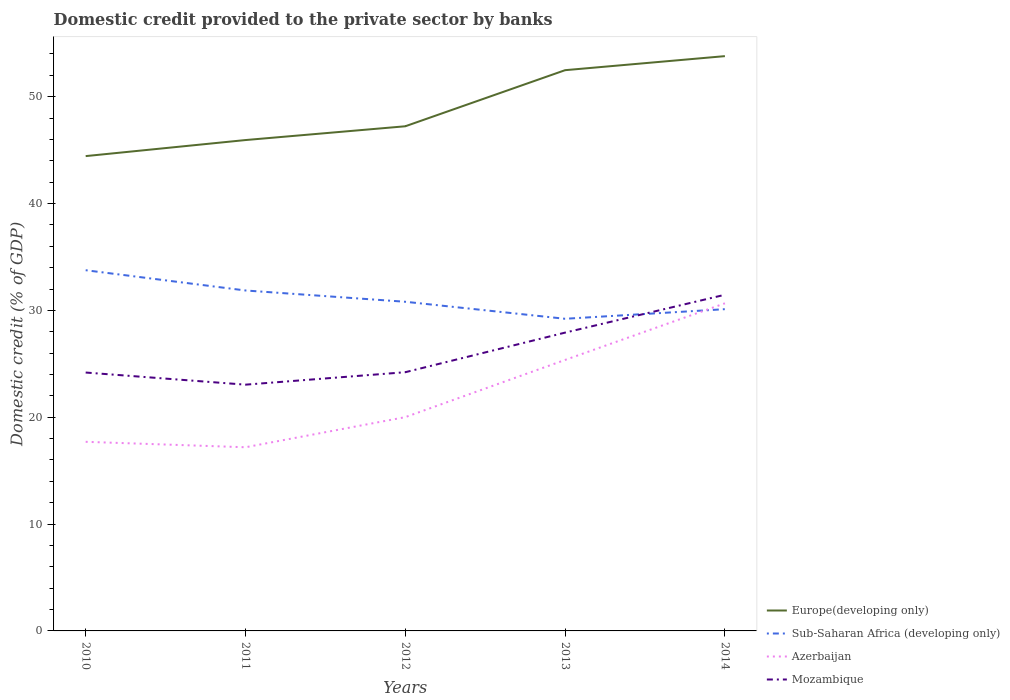Across all years, what is the maximum domestic credit provided to the private sector by banks in Sub-Saharan Africa (developing only)?
Offer a very short reply. 29.21. What is the total domestic credit provided to the private sector by banks in Mozambique in the graph?
Ensure brevity in your answer.  -3.54. What is the difference between the highest and the second highest domestic credit provided to the private sector by banks in Azerbaijan?
Keep it short and to the point. 13.47. What is the difference between the highest and the lowest domestic credit provided to the private sector by banks in Azerbaijan?
Your answer should be compact. 2. Is the domestic credit provided to the private sector by banks in Europe(developing only) strictly greater than the domestic credit provided to the private sector by banks in Azerbaijan over the years?
Your response must be concise. No. How many lines are there?
Your response must be concise. 4. How many years are there in the graph?
Your response must be concise. 5. Are the values on the major ticks of Y-axis written in scientific E-notation?
Provide a succinct answer. No. Does the graph contain grids?
Offer a terse response. No. How many legend labels are there?
Your answer should be compact. 4. How are the legend labels stacked?
Ensure brevity in your answer.  Vertical. What is the title of the graph?
Keep it short and to the point. Domestic credit provided to the private sector by banks. Does "Namibia" appear as one of the legend labels in the graph?
Offer a terse response. No. What is the label or title of the X-axis?
Provide a short and direct response. Years. What is the label or title of the Y-axis?
Give a very brief answer. Domestic credit (% of GDP). What is the Domestic credit (% of GDP) in Europe(developing only) in 2010?
Provide a succinct answer. 44.44. What is the Domestic credit (% of GDP) in Sub-Saharan Africa (developing only) in 2010?
Give a very brief answer. 33.76. What is the Domestic credit (% of GDP) in Azerbaijan in 2010?
Make the answer very short. 17.7. What is the Domestic credit (% of GDP) in Mozambique in 2010?
Provide a short and direct response. 24.18. What is the Domestic credit (% of GDP) in Europe(developing only) in 2011?
Make the answer very short. 45.94. What is the Domestic credit (% of GDP) in Sub-Saharan Africa (developing only) in 2011?
Ensure brevity in your answer.  31.86. What is the Domestic credit (% of GDP) in Azerbaijan in 2011?
Your answer should be compact. 17.19. What is the Domestic credit (% of GDP) of Mozambique in 2011?
Provide a short and direct response. 23.05. What is the Domestic credit (% of GDP) of Europe(developing only) in 2012?
Make the answer very short. 47.23. What is the Domestic credit (% of GDP) of Sub-Saharan Africa (developing only) in 2012?
Your answer should be compact. 30.81. What is the Domestic credit (% of GDP) of Azerbaijan in 2012?
Make the answer very short. 20.01. What is the Domestic credit (% of GDP) of Mozambique in 2012?
Give a very brief answer. 24.21. What is the Domestic credit (% of GDP) in Europe(developing only) in 2013?
Offer a terse response. 52.48. What is the Domestic credit (% of GDP) of Sub-Saharan Africa (developing only) in 2013?
Make the answer very short. 29.21. What is the Domestic credit (% of GDP) in Azerbaijan in 2013?
Your answer should be compact. 25.36. What is the Domestic credit (% of GDP) in Mozambique in 2013?
Make the answer very short. 27.92. What is the Domestic credit (% of GDP) in Europe(developing only) in 2014?
Your answer should be compact. 53.79. What is the Domestic credit (% of GDP) of Sub-Saharan Africa (developing only) in 2014?
Offer a very short reply. 30.11. What is the Domestic credit (% of GDP) in Azerbaijan in 2014?
Keep it short and to the point. 30.66. What is the Domestic credit (% of GDP) of Mozambique in 2014?
Make the answer very short. 31.46. Across all years, what is the maximum Domestic credit (% of GDP) of Europe(developing only)?
Give a very brief answer. 53.79. Across all years, what is the maximum Domestic credit (% of GDP) in Sub-Saharan Africa (developing only)?
Provide a short and direct response. 33.76. Across all years, what is the maximum Domestic credit (% of GDP) in Azerbaijan?
Your response must be concise. 30.66. Across all years, what is the maximum Domestic credit (% of GDP) of Mozambique?
Offer a terse response. 31.46. Across all years, what is the minimum Domestic credit (% of GDP) in Europe(developing only)?
Give a very brief answer. 44.44. Across all years, what is the minimum Domestic credit (% of GDP) of Sub-Saharan Africa (developing only)?
Keep it short and to the point. 29.21. Across all years, what is the minimum Domestic credit (% of GDP) of Azerbaijan?
Give a very brief answer. 17.19. Across all years, what is the minimum Domestic credit (% of GDP) of Mozambique?
Your answer should be very brief. 23.05. What is the total Domestic credit (% of GDP) of Europe(developing only) in the graph?
Your answer should be very brief. 243.88. What is the total Domestic credit (% of GDP) of Sub-Saharan Africa (developing only) in the graph?
Provide a short and direct response. 155.75. What is the total Domestic credit (% of GDP) in Azerbaijan in the graph?
Provide a short and direct response. 110.92. What is the total Domestic credit (% of GDP) in Mozambique in the graph?
Give a very brief answer. 130.82. What is the difference between the Domestic credit (% of GDP) of Europe(developing only) in 2010 and that in 2011?
Make the answer very short. -1.5. What is the difference between the Domestic credit (% of GDP) of Sub-Saharan Africa (developing only) in 2010 and that in 2011?
Your response must be concise. 1.9. What is the difference between the Domestic credit (% of GDP) in Azerbaijan in 2010 and that in 2011?
Offer a very short reply. 0.51. What is the difference between the Domestic credit (% of GDP) in Mozambique in 2010 and that in 2011?
Your answer should be compact. 1.14. What is the difference between the Domestic credit (% of GDP) in Europe(developing only) in 2010 and that in 2012?
Make the answer very short. -2.79. What is the difference between the Domestic credit (% of GDP) of Sub-Saharan Africa (developing only) in 2010 and that in 2012?
Give a very brief answer. 2.95. What is the difference between the Domestic credit (% of GDP) of Azerbaijan in 2010 and that in 2012?
Your response must be concise. -2.31. What is the difference between the Domestic credit (% of GDP) in Mozambique in 2010 and that in 2012?
Make the answer very short. -0.03. What is the difference between the Domestic credit (% of GDP) of Europe(developing only) in 2010 and that in 2013?
Provide a short and direct response. -8.04. What is the difference between the Domestic credit (% of GDP) of Sub-Saharan Africa (developing only) in 2010 and that in 2013?
Offer a terse response. 4.55. What is the difference between the Domestic credit (% of GDP) in Azerbaijan in 2010 and that in 2013?
Ensure brevity in your answer.  -7.66. What is the difference between the Domestic credit (% of GDP) of Mozambique in 2010 and that in 2013?
Your response must be concise. -3.74. What is the difference between the Domestic credit (% of GDP) of Europe(developing only) in 2010 and that in 2014?
Make the answer very short. -9.36. What is the difference between the Domestic credit (% of GDP) in Sub-Saharan Africa (developing only) in 2010 and that in 2014?
Your response must be concise. 3.65. What is the difference between the Domestic credit (% of GDP) in Azerbaijan in 2010 and that in 2014?
Give a very brief answer. -12.96. What is the difference between the Domestic credit (% of GDP) in Mozambique in 2010 and that in 2014?
Your answer should be very brief. -7.28. What is the difference between the Domestic credit (% of GDP) of Europe(developing only) in 2011 and that in 2012?
Offer a very short reply. -1.29. What is the difference between the Domestic credit (% of GDP) in Sub-Saharan Africa (developing only) in 2011 and that in 2012?
Give a very brief answer. 1.06. What is the difference between the Domestic credit (% of GDP) of Azerbaijan in 2011 and that in 2012?
Ensure brevity in your answer.  -2.82. What is the difference between the Domestic credit (% of GDP) in Mozambique in 2011 and that in 2012?
Offer a terse response. -1.17. What is the difference between the Domestic credit (% of GDP) of Europe(developing only) in 2011 and that in 2013?
Give a very brief answer. -6.54. What is the difference between the Domestic credit (% of GDP) of Sub-Saharan Africa (developing only) in 2011 and that in 2013?
Give a very brief answer. 2.65. What is the difference between the Domestic credit (% of GDP) in Azerbaijan in 2011 and that in 2013?
Offer a very short reply. -8.17. What is the difference between the Domestic credit (% of GDP) of Mozambique in 2011 and that in 2013?
Offer a very short reply. -4.87. What is the difference between the Domestic credit (% of GDP) of Europe(developing only) in 2011 and that in 2014?
Your answer should be compact. -7.85. What is the difference between the Domestic credit (% of GDP) in Azerbaijan in 2011 and that in 2014?
Offer a terse response. -13.47. What is the difference between the Domestic credit (% of GDP) of Mozambique in 2011 and that in 2014?
Offer a terse response. -8.41. What is the difference between the Domestic credit (% of GDP) of Europe(developing only) in 2012 and that in 2013?
Provide a short and direct response. -5.25. What is the difference between the Domestic credit (% of GDP) of Sub-Saharan Africa (developing only) in 2012 and that in 2013?
Offer a very short reply. 1.59. What is the difference between the Domestic credit (% of GDP) of Azerbaijan in 2012 and that in 2013?
Your answer should be compact. -5.35. What is the difference between the Domestic credit (% of GDP) of Mozambique in 2012 and that in 2013?
Give a very brief answer. -3.71. What is the difference between the Domestic credit (% of GDP) in Europe(developing only) in 2012 and that in 2014?
Provide a short and direct response. -6.56. What is the difference between the Domestic credit (% of GDP) of Sub-Saharan Africa (developing only) in 2012 and that in 2014?
Your answer should be compact. 0.69. What is the difference between the Domestic credit (% of GDP) of Azerbaijan in 2012 and that in 2014?
Your response must be concise. -10.65. What is the difference between the Domestic credit (% of GDP) in Mozambique in 2012 and that in 2014?
Keep it short and to the point. -7.25. What is the difference between the Domestic credit (% of GDP) of Europe(developing only) in 2013 and that in 2014?
Your answer should be compact. -1.31. What is the difference between the Domestic credit (% of GDP) in Sub-Saharan Africa (developing only) in 2013 and that in 2014?
Make the answer very short. -0.9. What is the difference between the Domestic credit (% of GDP) of Azerbaijan in 2013 and that in 2014?
Make the answer very short. -5.3. What is the difference between the Domestic credit (% of GDP) of Mozambique in 2013 and that in 2014?
Your answer should be very brief. -3.54. What is the difference between the Domestic credit (% of GDP) of Europe(developing only) in 2010 and the Domestic credit (% of GDP) of Sub-Saharan Africa (developing only) in 2011?
Ensure brevity in your answer.  12.58. What is the difference between the Domestic credit (% of GDP) in Europe(developing only) in 2010 and the Domestic credit (% of GDP) in Azerbaijan in 2011?
Make the answer very short. 27.25. What is the difference between the Domestic credit (% of GDP) of Europe(developing only) in 2010 and the Domestic credit (% of GDP) of Mozambique in 2011?
Your answer should be very brief. 21.39. What is the difference between the Domestic credit (% of GDP) of Sub-Saharan Africa (developing only) in 2010 and the Domestic credit (% of GDP) of Azerbaijan in 2011?
Ensure brevity in your answer.  16.57. What is the difference between the Domestic credit (% of GDP) in Sub-Saharan Africa (developing only) in 2010 and the Domestic credit (% of GDP) in Mozambique in 2011?
Your answer should be compact. 10.71. What is the difference between the Domestic credit (% of GDP) in Azerbaijan in 2010 and the Domestic credit (% of GDP) in Mozambique in 2011?
Give a very brief answer. -5.35. What is the difference between the Domestic credit (% of GDP) of Europe(developing only) in 2010 and the Domestic credit (% of GDP) of Sub-Saharan Africa (developing only) in 2012?
Provide a succinct answer. 13.63. What is the difference between the Domestic credit (% of GDP) of Europe(developing only) in 2010 and the Domestic credit (% of GDP) of Azerbaijan in 2012?
Provide a succinct answer. 24.43. What is the difference between the Domestic credit (% of GDP) in Europe(developing only) in 2010 and the Domestic credit (% of GDP) in Mozambique in 2012?
Your answer should be very brief. 20.23. What is the difference between the Domestic credit (% of GDP) in Sub-Saharan Africa (developing only) in 2010 and the Domestic credit (% of GDP) in Azerbaijan in 2012?
Offer a very short reply. 13.75. What is the difference between the Domestic credit (% of GDP) in Sub-Saharan Africa (developing only) in 2010 and the Domestic credit (% of GDP) in Mozambique in 2012?
Your response must be concise. 9.55. What is the difference between the Domestic credit (% of GDP) in Azerbaijan in 2010 and the Domestic credit (% of GDP) in Mozambique in 2012?
Ensure brevity in your answer.  -6.51. What is the difference between the Domestic credit (% of GDP) in Europe(developing only) in 2010 and the Domestic credit (% of GDP) in Sub-Saharan Africa (developing only) in 2013?
Your response must be concise. 15.23. What is the difference between the Domestic credit (% of GDP) of Europe(developing only) in 2010 and the Domestic credit (% of GDP) of Azerbaijan in 2013?
Your answer should be very brief. 19.08. What is the difference between the Domestic credit (% of GDP) in Europe(developing only) in 2010 and the Domestic credit (% of GDP) in Mozambique in 2013?
Your answer should be compact. 16.52. What is the difference between the Domestic credit (% of GDP) in Sub-Saharan Africa (developing only) in 2010 and the Domestic credit (% of GDP) in Azerbaijan in 2013?
Keep it short and to the point. 8.4. What is the difference between the Domestic credit (% of GDP) in Sub-Saharan Africa (developing only) in 2010 and the Domestic credit (% of GDP) in Mozambique in 2013?
Your answer should be very brief. 5.84. What is the difference between the Domestic credit (% of GDP) in Azerbaijan in 2010 and the Domestic credit (% of GDP) in Mozambique in 2013?
Ensure brevity in your answer.  -10.22. What is the difference between the Domestic credit (% of GDP) in Europe(developing only) in 2010 and the Domestic credit (% of GDP) in Sub-Saharan Africa (developing only) in 2014?
Offer a terse response. 14.33. What is the difference between the Domestic credit (% of GDP) of Europe(developing only) in 2010 and the Domestic credit (% of GDP) of Azerbaijan in 2014?
Your answer should be very brief. 13.78. What is the difference between the Domestic credit (% of GDP) in Europe(developing only) in 2010 and the Domestic credit (% of GDP) in Mozambique in 2014?
Make the answer very short. 12.98. What is the difference between the Domestic credit (% of GDP) of Sub-Saharan Africa (developing only) in 2010 and the Domestic credit (% of GDP) of Azerbaijan in 2014?
Make the answer very short. 3.1. What is the difference between the Domestic credit (% of GDP) in Sub-Saharan Africa (developing only) in 2010 and the Domestic credit (% of GDP) in Mozambique in 2014?
Offer a terse response. 2.3. What is the difference between the Domestic credit (% of GDP) of Azerbaijan in 2010 and the Domestic credit (% of GDP) of Mozambique in 2014?
Your answer should be compact. -13.76. What is the difference between the Domestic credit (% of GDP) of Europe(developing only) in 2011 and the Domestic credit (% of GDP) of Sub-Saharan Africa (developing only) in 2012?
Make the answer very short. 15.13. What is the difference between the Domestic credit (% of GDP) in Europe(developing only) in 2011 and the Domestic credit (% of GDP) in Azerbaijan in 2012?
Your answer should be compact. 25.93. What is the difference between the Domestic credit (% of GDP) in Europe(developing only) in 2011 and the Domestic credit (% of GDP) in Mozambique in 2012?
Keep it short and to the point. 21.73. What is the difference between the Domestic credit (% of GDP) in Sub-Saharan Africa (developing only) in 2011 and the Domestic credit (% of GDP) in Azerbaijan in 2012?
Make the answer very short. 11.85. What is the difference between the Domestic credit (% of GDP) in Sub-Saharan Africa (developing only) in 2011 and the Domestic credit (% of GDP) in Mozambique in 2012?
Offer a terse response. 7.65. What is the difference between the Domestic credit (% of GDP) in Azerbaijan in 2011 and the Domestic credit (% of GDP) in Mozambique in 2012?
Provide a short and direct response. -7.02. What is the difference between the Domestic credit (% of GDP) in Europe(developing only) in 2011 and the Domestic credit (% of GDP) in Sub-Saharan Africa (developing only) in 2013?
Your response must be concise. 16.73. What is the difference between the Domestic credit (% of GDP) of Europe(developing only) in 2011 and the Domestic credit (% of GDP) of Azerbaijan in 2013?
Offer a terse response. 20.58. What is the difference between the Domestic credit (% of GDP) of Europe(developing only) in 2011 and the Domestic credit (% of GDP) of Mozambique in 2013?
Your answer should be very brief. 18.02. What is the difference between the Domestic credit (% of GDP) in Sub-Saharan Africa (developing only) in 2011 and the Domestic credit (% of GDP) in Mozambique in 2013?
Your answer should be compact. 3.94. What is the difference between the Domestic credit (% of GDP) of Azerbaijan in 2011 and the Domestic credit (% of GDP) of Mozambique in 2013?
Give a very brief answer. -10.73. What is the difference between the Domestic credit (% of GDP) in Europe(developing only) in 2011 and the Domestic credit (% of GDP) in Sub-Saharan Africa (developing only) in 2014?
Provide a short and direct response. 15.83. What is the difference between the Domestic credit (% of GDP) of Europe(developing only) in 2011 and the Domestic credit (% of GDP) of Azerbaijan in 2014?
Offer a terse response. 15.28. What is the difference between the Domestic credit (% of GDP) of Europe(developing only) in 2011 and the Domestic credit (% of GDP) of Mozambique in 2014?
Provide a short and direct response. 14.48. What is the difference between the Domestic credit (% of GDP) in Sub-Saharan Africa (developing only) in 2011 and the Domestic credit (% of GDP) in Azerbaijan in 2014?
Provide a succinct answer. 1.2. What is the difference between the Domestic credit (% of GDP) in Sub-Saharan Africa (developing only) in 2011 and the Domestic credit (% of GDP) in Mozambique in 2014?
Offer a terse response. 0.4. What is the difference between the Domestic credit (% of GDP) in Azerbaijan in 2011 and the Domestic credit (% of GDP) in Mozambique in 2014?
Your answer should be compact. -14.27. What is the difference between the Domestic credit (% of GDP) of Europe(developing only) in 2012 and the Domestic credit (% of GDP) of Sub-Saharan Africa (developing only) in 2013?
Keep it short and to the point. 18.02. What is the difference between the Domestic credit (% of GDP) of Europe(developing only) in 2012 and the Domestic credit (% of GDP) of Azerbaijan in 2013?
Your response must be concise. 21.87. What is the difference between the Domestic credit (% of GDP) of Europe(developing only) in 2012 and the Domestic credit (% of GDP) of Mozambique in 2013?
Your response must be concise. 19.31. What is the difference between the Domestic credit (% of GDP) in Sub-Saharan Africa (developing only) in 2012 and the Domestic credit (% of GDP) in Azerbaijan in 2013?
Provide a succinct answer. 5.44. What is the difference between the Domestic credit (% of GDP) of Sub-Saharan Africa (developing only) in 2012 and the Domestic credit (% of GDP) of Mozambique in 2013?
Ensure brevity in your answer.  2.89. What is the difference between the Domestic credit (% of GDP) of Azerbaijan in 2012 and the Domestic credit (% of GDP) of Mozambique in 2013?
Provide a short and direct response. -7.91. What is the difference between the Domestic credit (% of GDP) of Europe(developing only) in 2012 and the Domestic credit (% of GDP) of Sub-Saharan Africa (developing only) in 2014?
Make the answer very short. 17.12. What is the difference between the Domestic credit (% of GDP) of Europe(developing only) in 2012 and the Domestic credit (% of GDP) of Azerbaijan in 2014?
Give a very brief answer. 16.57. What is the difference between the Domestic credit (% of GDP) in Europe(developing only) in 2012 and the Domestic credit (% of GDP) in Mozambique in 2014?
Keep it short and to the point. 15.77. What is the difference between the Domestic credit (% of GDP) in Sub-Saharan Africa (developing only) in 2012 and the Domestic credit (% of GDP) in Azerbaijan in 2014?
Your answer should be compact. 0.14. What is the difference between the Domestic credit (% of GDP) of Sub-Saharan Africa (developing only) in 2012 and the Domestic credit (% of GDP) of Mozambique in 2014?
Your answer should be compact. -0.66. What is the difference between the Domestic credit (% of GDP) in Azerbaijan in 2012 and the Domestic credit (% of GDP) in Mozambique in 2014?
Give a very brief answer. -11.45. What is the difference between the Domestic credit (% of GDP) in Europe(developing only) in 2013 and the Domestic credit (% of GDP) in Sub-Saharan Africa (developing only) in 2014?
Give a very brief answer. 22.37. What is the difference between the Domestic credit (% of GDP) in Europe(developing only) in 2013 and the Domestic credit (% of GDP) in Azerbaijan in 2014?
Your answer should be very brief. 21.82. What is the difference between the Domestic credit (% of GDP) of Europe(developing only) in 2013 and the Domestic credit (% of GDP) of Mozambique in 2014?
Provide a short and direct response. 21.02. What is the difference between the Domestic credit (% of GDP) in Sub-Saharan Africa (developing only) in 2013 and the Domestic credit (% of GDP) in Azerbaijan in 2014?
Give a very brief answer. -1.45. What is the difference between the Domestic credit (% of GDP) of Sub-Saharan Africa (developing only) in 2013 and the Domestic credit (% of GDP) of Mozambique in 2014?
Your response must be concise. -2.25. What is the difference between the Domestic credit (% of GDP) in Azerbaijan in 2013 and the Domestic credit (% of GDP) in Mozambique in 2014?
Make the answer very short. -6.1. What is the average Domestic credit (% of GDP) of Europe(developing only) per year?
Keep it short and to the point. 48.78. What is the average Domestic credit (% of GDP) of Sub-Saharan Africa (developing only) per year?
Keep it short and to the point. 31.15. What is the average Domestic credit (% of GDP) in Azerbaijan per year?
Your response must be concise. 22.18. What is the average Domestic credit (% of GDP) of Mozambique per year?
Provide a short and direct response. 26.16. In the year 2010, what is the difference between the Domestic credit (% of GDP) of Europe(developing only) and Domestic credit (% of GDP) of Sub-Saharan Africa (developing only)?
Offer a very short reply. 10.68. In the year 2010, what is the difference between the Domestic credit (% of GDP) of Europe(developing only) and Domestic credit (% of GDP) of Azerbaijan?
Keep it short and to the point. 26.74. In the year 2010, what is the difference between the Domestic credit (% of GDP) in Europe(developing only) and Domestic credit (% of GDP) in Mozambique?
Offer a terse response. 20.26. In the year 2010, what is the difference between the Domestic credit (% of GDP) of Sub-Saharan Africa (developing only) and Domestic credit (% of GDP) of Azerbaijan?
Offer a terse response. 16.06. In the year 2010, what is the difference between the Domestic credit (% of GDP) in Sub-Saharan Africa (developing only) and Domestic credit (% of GDP) in Mozambique?
Ensure brevity in your answer.  9.58. In the year 2010, what is the difference between the Domestic credit (% of GDP) in Azerbaijan and Domestic credit (% of GDP) in Mozambique?
Provide a succinct answer. -6.48. In the year 2011, what is the difference between the Domestic credit (% of GDP) in Europe(developing only) and Domestic credit (% of GDP) in Sub-Saharan Africa (developing only)?
Ensure brevity in your answer.  14.08. In the year 2011, what is the difference between the Domestic credit (% of GDP) of Europe(developing only) and Domestic credit (% of GDP) of Azerbaijan?
Make the answer very short. 28.75. In the year 2011, what is the difference between the Domestic credit (% of GDP) in Europe(developing only) and Domestic credit (% of GDP) in Mozambique?
Make the answer very short. 22.89. In the year 2011, what is the difference between the Domestic credit (% of GDP) in Sub-Saharan Africa (developing only) and Domestic credit (% of GDP) in Azerbaijan?
Offer a terse response. 14.67. In the year 2011, what is the difference between the Domestic credit (% of GDP) in Sub-Saharan Africa (developing only) and Domestic credit (% of GDP) in Mozambique?
Your response must be concise. 8.82. In the year 2011, what is the difference between the Domestic credit (% of GDP) of Azerbaijan and Domestic credit (% of GDP) of Mozambique?
Provide a short and direct response. -5.86. In the year 2012, what is the difference between the Domestic credit (% of GDP) in Europe(developing only) and Domestic credit (% of GDP) in Sub-Saharan Africa (developing only)?
Provide a short and direct response. 16.42. In the year 2012, what is the difference between the Domestic credit (% of GDP) of Europe(developing only) and Domestic credit (% of GDP) of Azerbaijan?
Offer a very short reply. 27.22. In the year 2012, what is the difference between the Domestic credit (% of GDP) in Europe(developing only) and Domestic credit (% of GDP) in Mozambique?
Ensure brevity in your answer.  23.02. In the year 2012, what is the difference between the Domestic credit (% of GDP) in Sub-Saharan Africa (developing only) and Domestic credit (% of GDP) in Azerbaijan?
Your answer should be compact. 10.8. In the year 2012, what is the difference between the Domestic credit (% of GDP) in Sub-Saharan Africa (developing only) and Domestic credit (% of GDP) in Mozambique?
Keep it short and to the point. 6.59. In the year 2012, what is the difference between the Domestic credit (% of GDP) of Azerbaijan and Domestic credit (% of GDP) of Mozambique?
Offer a very short reply. -4.2. In the year 2013, what is the difference between the Domestic credit (% of GDP) in Europe(developing only) and Domestic credit (% of GDP) in Sub-Saharan Africa (developing only)?
Give a very brief answer. 23.27. In the year 2013, what is the difference between the Domestic credit (% of GDP) of Europe(developing only) and Domestic credit (% of GDP) of Azerbaijan?
Your answer should be very brief. 27.12. In the year 2013, what is the difference between the Domestic credit (% of GDP) in Europe(developing only) and Domestic credit (% of GDP) in Mozambique?
Your response must be concise. 24.56. In the year 2013, what is the difference between the Domestic credit (% of GDP) of Sub-Saharan Africa (developing only) and Domestic credit (% of GDP) of Azerbaijan?
Ensure brevity in your answer.  3.85. In the year 2013, what is the difference between the Domestic credit (% of GDP) in Sub-Saharan Africa (developing only) and Domestic credit (% of GDP) in Mozambique?
Offer a very short reply. 1.29. In the year 2013, what is the difference between the Domestic credit (% of GDP) in Azerbaijan and Domestic credit (% of GDP) in Mozambique?
Make the answer very short. -2.56. In the year 2014, what is the difference between the Domestic credit (% of GDP) of Europe(developing only) and Domestic credit (% of GDP) of Sub-Saharan Africa (developing only)?
Your answer should be very brief. 23.68. In the year 2014, what is the difference between the Domestic credit (% of GDP) of Europe(developing only) and Domestic credit (% of GDP) of Azerbaijan?
Keep it short and to the point. 23.13. In the year 2014, what is the difference between the Domestic credit (% of GDP) of Europe(developing only) and Domestic credit (% of GDP) of Mozambique?
Your response must be concise. 22.33. In the year 2014, what is the difference between the Domestic credit (% of GDP) in Sub-Saharan Africa (developing only) and Domestic credit (% of GDP) in Azerbaijan?
Give a very brief answer. -0.55. In the year 2014, what is the difference between the Domestic credit (% of GDP) in Sub-Saharan Africa (developing only) and Domestic credit (% of GDP) in Mozambique?
Provide a short and direct response. -1.35. In the year 2014, what is the difference between the Domestic credit (% of GDP) in Azerbaijan and Domestic credit (% of GDP) in Mozambique?
Keep it short and to the point. -0.8. What is the ratio of the Domestic credit (% of GDP) of Europe(developing only) in 2010 to that in 2011?
Provide a short and direct response. 0.97. What is the ratio of the Domestic credit (% of GDP) of Sub-Saharan Africa (developing only) in 2010 to that in 2011?
Offer a very short reply. 1.06. What is the ratio of the Domestic credit (% of GDP) of Azerbaijan in 2010 to that in 2011?
Your answer should be compact. 1.03. What is the ratio of the Domestic credit (% of GDP) in Mozambique in 2010 to that in 2011?
Provide a succinct answer. 1.05. What is the ratio of the Domestic credit (% of GDP) in Europe(developing only) in 2010 to that in 2012?
Offer a very short reply. 0.94. What is the ratio of the Domestic credit (% of GDP) in Sub-Saharan Africa (developing only) in 2010 to that in 2012?
Provide a short and direct response. 1.1. What is the ratio of the Domestic credit (% of GDP) of Azerbaijan in 2010 to that in 2012?
Give a very brief answer. 0.88. What is the ratio of the Domestic credit (% of GDP) in Europe(developing only) in 2010 to that in 2013?
Ensure brevity in your answer.  0.85. What is the ratio of the Domestic credit (% of GDP) in Sub-Saharan Africa (developing only) in 2010 to that in 2013?
Your answer should be very brief. 1.16. What is the ratio of the Domestic credit (% of GDP) in Azerbaijan in 2010 to that in 2013?
Provide a short and direct response. 0.7. What is the ratio of the Domestic credit (% of GDP) in Mozambique in 2010 to that in 2013?
Your answer should be compact. 0.87. What is the ratio of the Domestic credit (% of GDP) in Europe(developing only) in 2010 to that in 2014?
Keep it short and to the point. 0.83. What is the ratio of the Domestic credit (% of GDP) of Sub-Saharan Africa (developing only) in 2010 to that in 2014?
Your response must be concise. 1.12. What is the ratio of the Domestic credit (% of GDP) of Azerbaijan in 2010 to that in 2014?
Offer a terse response. 0.58. What is the ratio of the Domestic credit (% of GDP) in Mozambique in 2010 to that in 2014?
Provide a short and direct response. 0.77. What is the ratio of the Domestic credit (% of GDP) in Europe(developing only) in 2011 to that in 2012?
Offer a terse response. 0.97. What is the ratio of the Domestic credit (% of GDP) in Sub-Saharan Africa (developing only) in 2011 to that in 2012?
Your answer should be very brief. 1.03. What is the ratio of the Domestic credit (% of GDP) of Azerbaijan in 2011 to that in 2012?
Keep it short and to the point. 0.86. What is the ratio of the Domestic credit (% of GDP) of Mozambique in 2011 to that in 2012?
Provide a short and direct response. 0.95. What is the ratio of the Domestic credit (% of GDP) in Europe(developing only) in 2011 to that in 2013?
Your answer should be very brief. 0.88. What is the ratio of the Domestic credit (% of GDP) in Sub-Saharan Africa (developing only) in 2011 to that in 2013?
Your answer should be compact. 1.09. What is the ratio of the Domestic credit (% of GDP) in Azerbaijan in 2011 to that in 2013?
Offer a very short reply. 0.68. What is the ratio of the Domestic credit (% of GDP) of Mozambique in 2011 to that in 2013?
Provide a succinct answer. 0.83. What is the ratio of the Domestic credit (% of GDP) of Europe(developing only) in 2011 to that in 2014?
Give a very brief answer. 0.85. What is the ratio of the Domestic credit (% of GDP) of Sub-Saharan Africa (developing only) in 2011 to that in 2014?
Your response must be concise. 1.06. What is the ratio of the Domestic credit (% of GDP) in Azerbaijan in 2011 to that in 2014?
Your answer should be very brief. 0.56. What is the ratio of the Domestic credit (% of GDP) in Mozambique in 2011 to that in 2014?
Give a very brief answer. 0.73. What is the ratio of the Domestic credit (% of GDP) of Europe(developing only) in 2012 to that in 2013?
Your answer should be very brief. 0.9. What is the ratio of the Domestic credit (% of GDP) of Sub-Saharan Africa (developing only) in 2012 to that in 2013?
Ensure brevity in your answer.  1.05. What is the ratio of the Domestic credit (% of GDP) of Azerbaijan in 2012 to that in 2013?
Your answer should be very brief. 0.79. What is the ratio of the Domestic credit (% of GDP) in Mozambique in 2012 to that in 2013?
Provide a short and direct response. 0.87. What is the ratio of the Domestic credit (% of GDP) in Europe(developing only) in 2012 to that in 2014?
Offer a terse response. 0.88. What is the ratio of the Domestic credit (% of GDP) in Azerbaijan in 2012 to that in 2014?
Make the answer very short. 0.65. What is the ratio of the Domestic credit (% of GDP) in Mozambique in 2012 to that in 2014?
Provide a succinct answer. 0.77. What is the ratio of the Domestic credit (% of GDP) in Europe(developing only) in 2013 to that in 2014?
Offer a terse response. 0.98. What is the ratio of the Domestic credit (% of GDP) in Sub-Saharan Africa (developing only) in 2013 to that in 2014?
Your answer should be compact. 0.97. What is the ratio of the Domestic credit (% of GDP) in Azerbaijan in 2013 to that in 2014?
Ensure brevity in your answer.  0.83. What is the ratio of the Domestic credit (% of GDP) in Mozambique in 2013 to that in 2014?
Make the answer very short. 0.89. What is the difference between the highest and the second highest Domestic credit (% of GDP) of Europe(developing only)?
Keep it short and to the point. 1.31. What is the difference between the highest and the second highest Domestic credit (% of GDP) in Sub-Saharan Africa (developing only)?
Ensure brevity in your answer.  1.9. What is the difference between the highest and the second highest Domestic credit (% of GDP) in Azerbaijan?
Your answer should be compact. 5.3. What is the difference between the highest and the second highest Domestic credit (% of GDP) of Mozambique?
Give a very brief answer. 3.54. What is the difference between the highest and the lowest Domestic credit (% of GDP) of Europe(developing only)?
Your response must be concise. 9.36. What is the difference between the highest and the lowest Domestic credit (% of GDP) in Sub-Saharan Africa (developing only)?
Your response must be concise. 4.55. What is the difference between the highest and the lowest Domestic credit (% of GDP) of Azerbaijan?
Your answer should be compact. 13.47. What is the difference between the highest and the lowest Domestic credit (% of GDP) in Mozambique?
Your answer should be very brief. 8.41. 